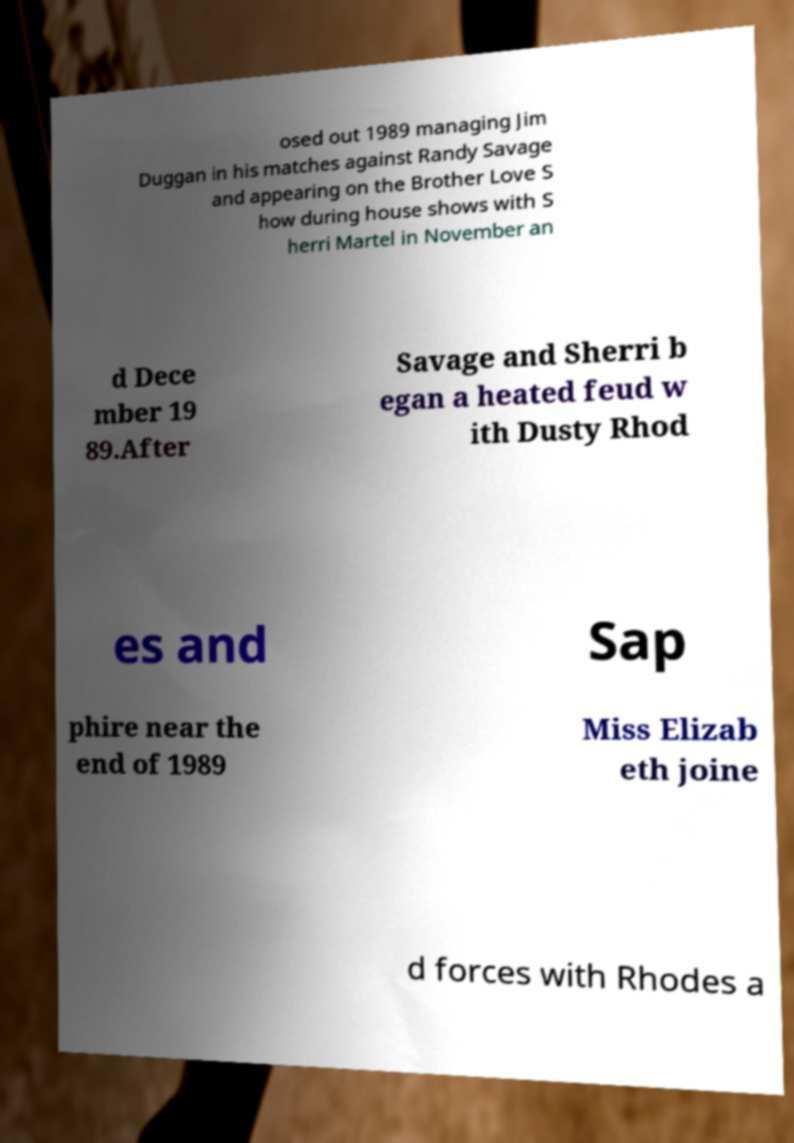Could you assist in decoding the text presented in this image and type it out clearly? osed out 1989 managing Jim Duggan in his matches against Randy Savage and appearing on the Brother Love S how during house shows with S herri Martel in November an d Dece mber 19 89.After Savage and Sherri b egan a heated feud w ith Dusty Rhod es and Sap phire near the end of 1989 Miss Elizab eth joine d forces with Rhodes a 